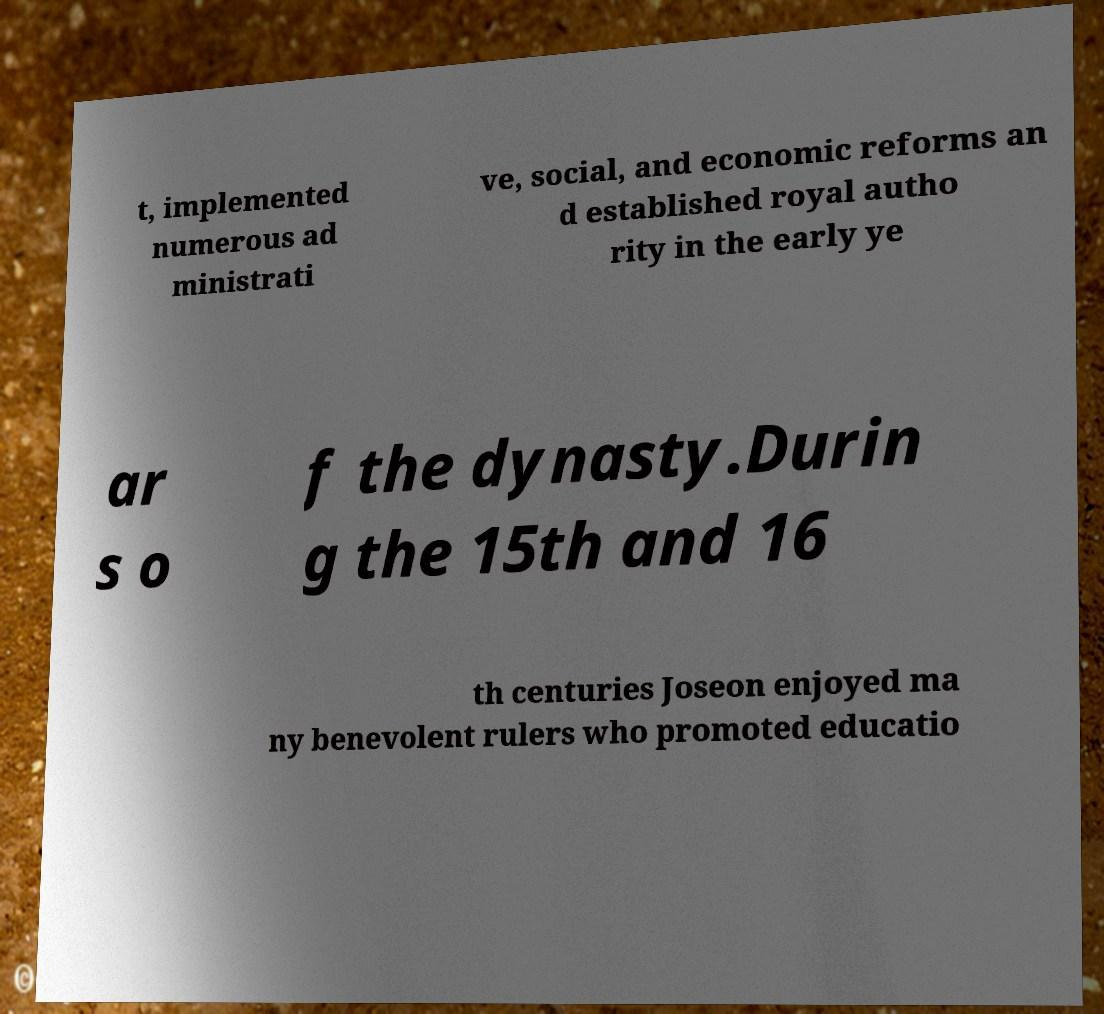Please read and relay the text visible in this image. What does it say? t, implemented numerous ad ministrati ve, social, and economic reforms an d established royal autho rity in the early ye ar s o f the dynasty.Durin g the 15th and 16 th centuries Joseon enjoyed ma ny benevolent rulers who promoted educatio 